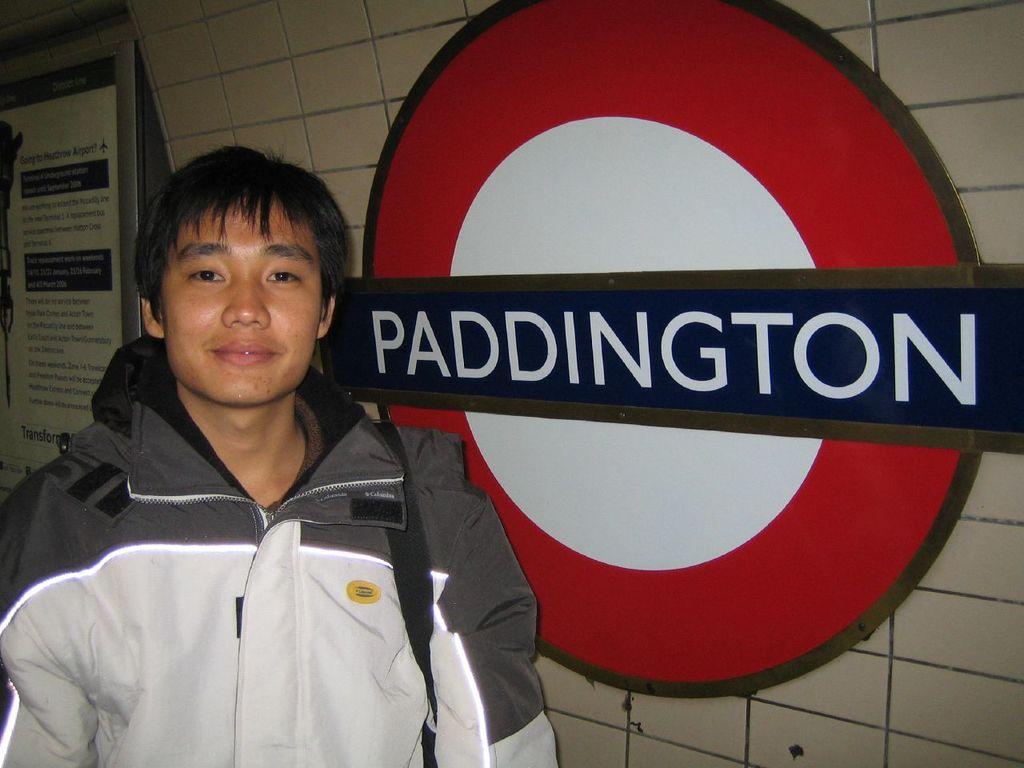Where is this person?
Give a very brief answer. Paddington. 